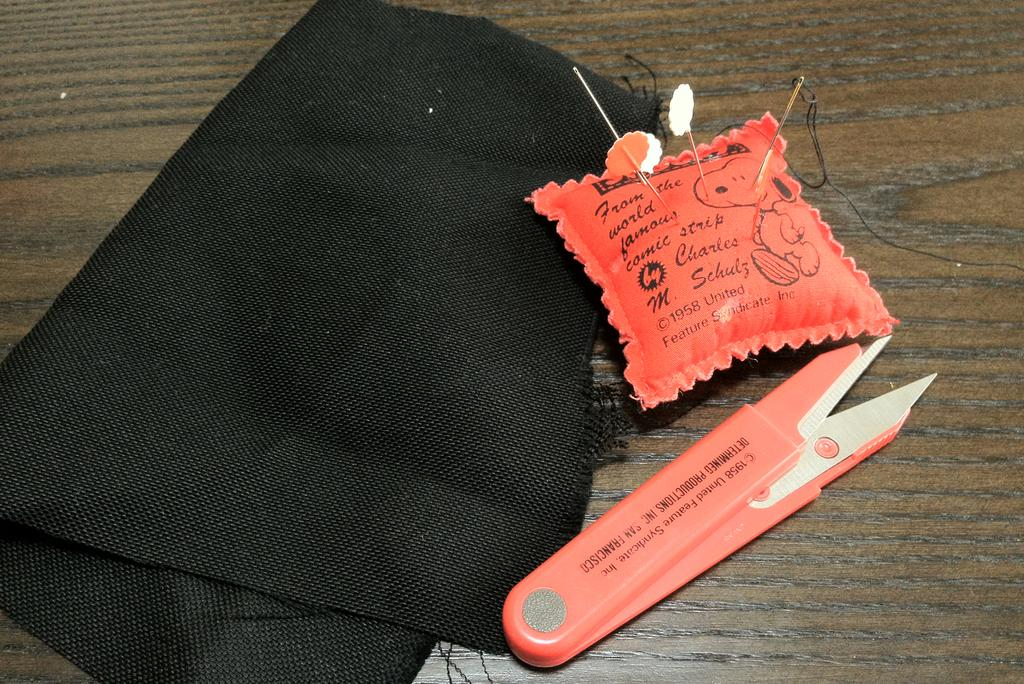<image>
Relay a brief, clear account of the picture shown. A pin cushion has Charles Schulz's name on it and a picture of Snoopy. 